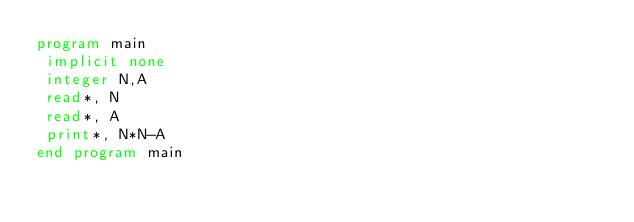<code> <loc_0><loc_0><loc_500><loc_500><_FORTRAN_>program main
 implicit none
 integer N,A
 read*, N
 read*, A
 print*, N*N-A
end program main</code> 